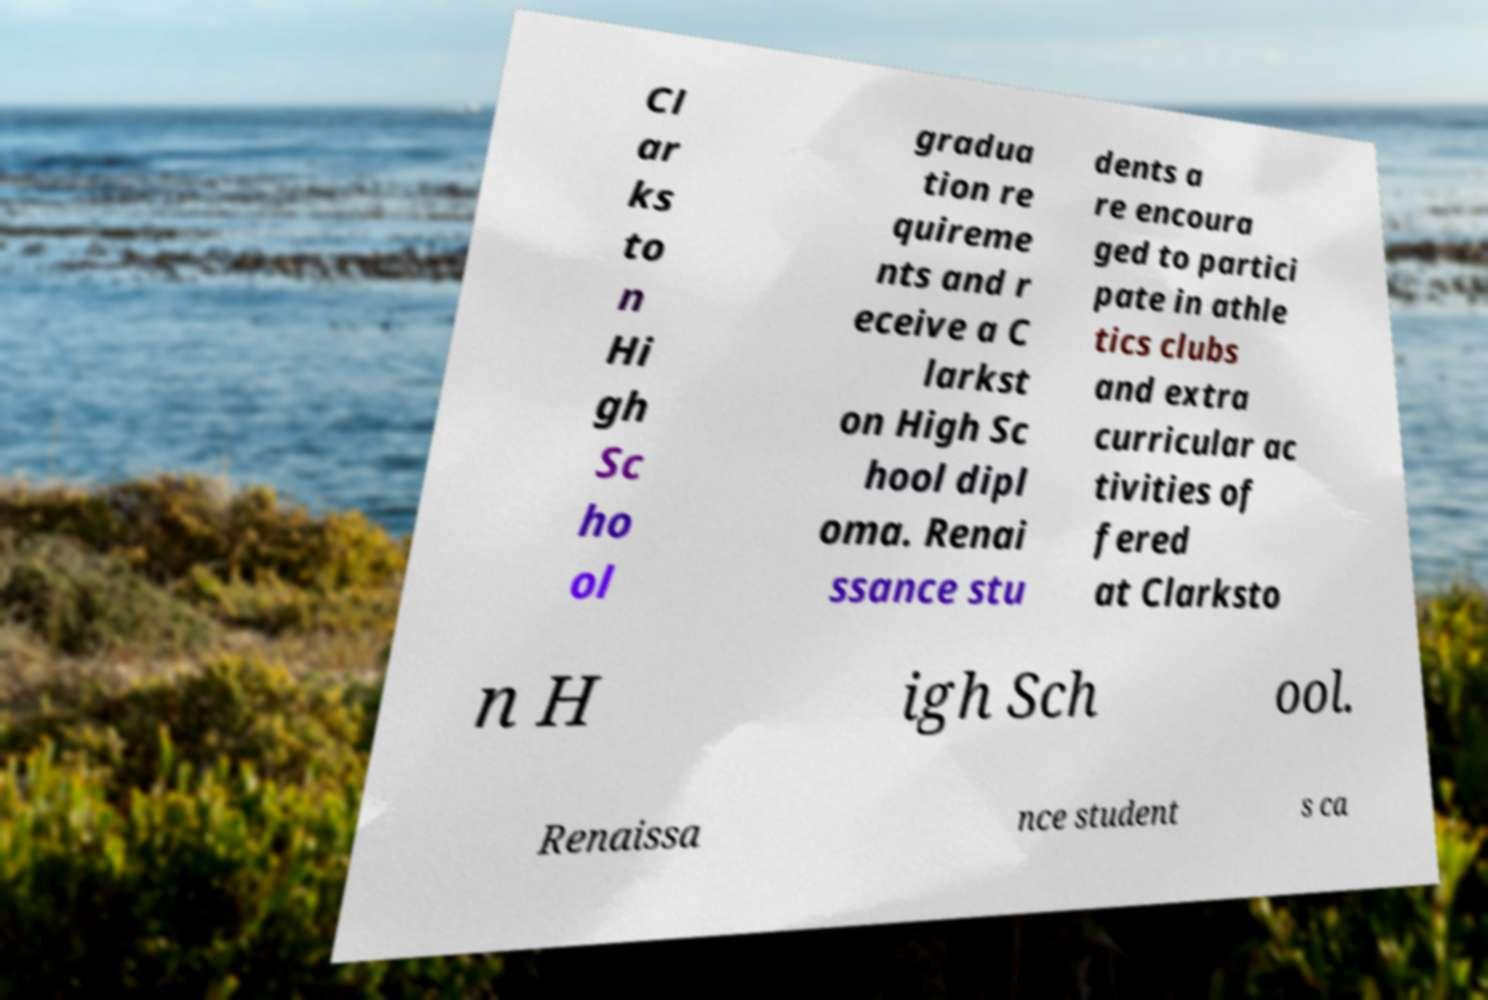Could you assist in decoding the text presented in this image and type it out clearly? Cl ar ks to n Hi gh Sc ho ol gradua tion re quireme nts and r eceive a C larkst on High Sc hool dipl oma. Renai ssance stu dents a re encoura ged to partici pate in athle tics clubs and extra curricular ac tivities of fered at Clarksto n H igh Sch ool. Renaissa nce student s ca 